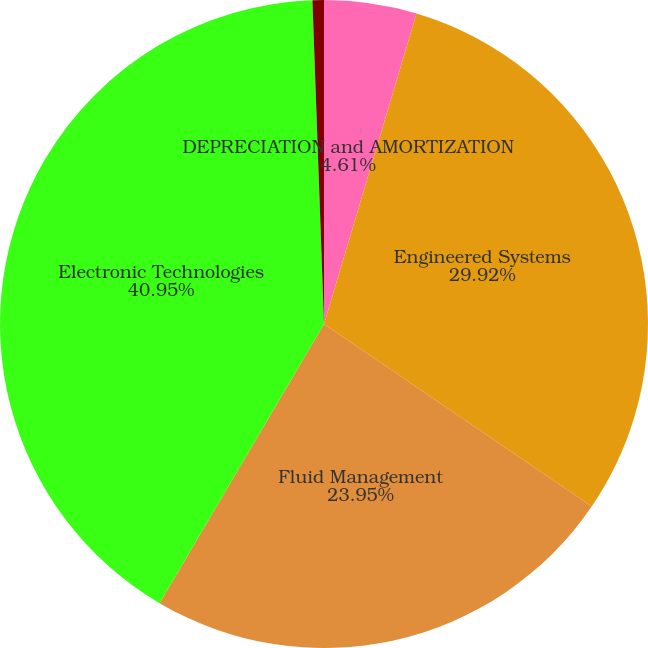Convert chart. <chart><loc_0><loc_0><loc_500><loc_500><pie_chart><fcel>DEPRECIATION and AMORTIZATION<fcel>Engineered Systems<fcel>Fluid Management<fcel>Electronic Technologies<fcel>Corporate<nl><fcel>4.61%<fcel>29.92%<fcel>23.95%<fcel>40.96%<fcel>0.57%<nl></chart> 